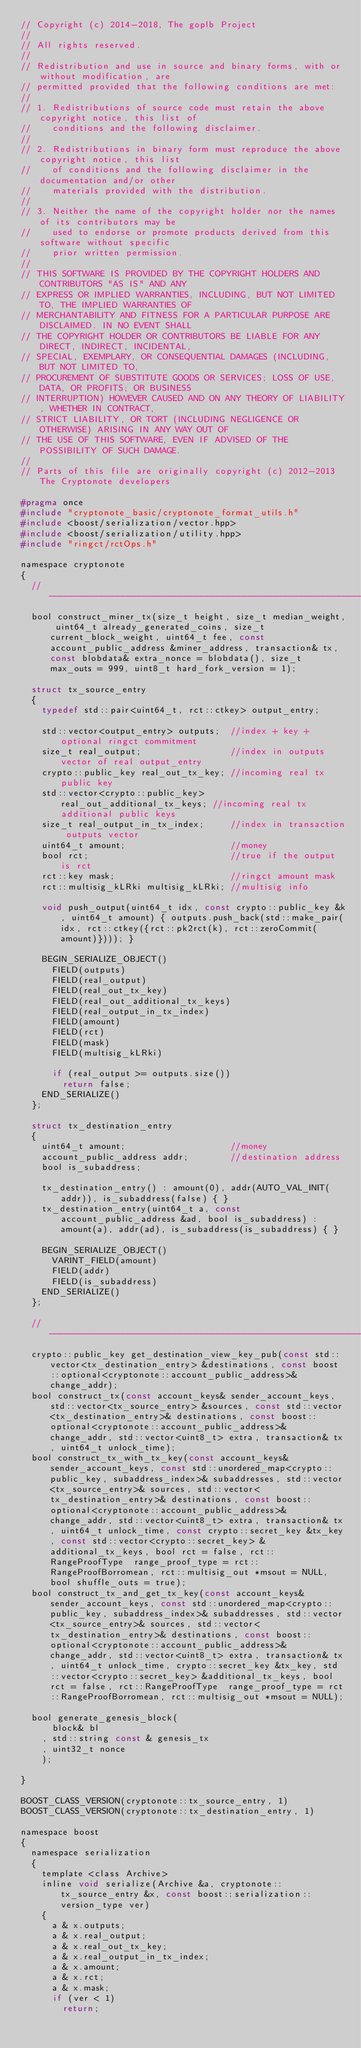Convert code to text. <code><loc_0><loc_0><loc_500><loc_500><_C_>// Copyright (c) 2014-2018, The goplb Project
// 
// All rights reserved.
// 
// Redistribution and use in source and binary forms, with or without modification, are
// permitted provided that the following conditions are met:
// 
// 1. Redistributions of source code must retain the above copyright notice, this list of
//    conditions and the following disclaimer.
// 
// 2. Redistributions in binary form must reproduce the above copyright notice, this list
//    of conditions and the following disclaimer in the documentation and/or other
//    materials provided with the distribution.
// 
// 3. Neither the name of the copyright holder nor the names of its contributors may be
//    used to endorse or promote products derived from this software without specific
//    prior written permission.
// 
// THIS SOFTWARE IS PROVIDED BY THE COPYRIGHT HOLDERS AND CONTRIBUTORS "AS IS" AND ANY
// EXPRESS OR IMPLIED WARRANTIES, INCLUDING, BUT NOT LIMITED TO, THE IMPLIED WARRANTIES OF
// MERCHANTABILITY AND FITNESS FOR A PARTICULAR PURPOSE ARE DISCLAIMED. IN NO EVENT SHALL
// THE COPYRIGHT HOLDER OR CONTRIBUTORS BE LIABLE FOR ANY DIRECT, INDIRECT, INCIDENTAL,
// SPECIAL, EXEMPLARY, OR CONSEQUENTIAL DAMAGES (INCLUDING, BUT NOT LIMITED TO,
// PROCUREMENT OF SUBSTITUTE GOODS OR SERVICES; LOSS OF USE, DATA, OR PROFITS; OR BUSINESS
// INTERRUPTION) HOWEVER CAUSED AND ON ANY THEORY OF LIABILITY, WHETHER IN CONTRACT,
// STRICT LIABILITY, OR TORT (INCLUDING NEGLIGENCE OR OTHERWISE) ARISING IN ANY WAY OUT OF
// THE USE OF THIS SOFTWARE, EVEN IF ADVISED OF THE POSSIBILITY OF SUCH DAMAGE.
// 
// Parts of this file are originally copyright (c) 2012-2013 The Cryptonote developers

#pragma once
#include "cryptonote_basic/cryptonote_format_utils.h"
#include <boost/serialization/vector.hpp>
#include <boost/serialization/utility.hpp>
#include "ringct/rctOps.h"

namespace cryptonote
{
  //---------------------------------------------------------------
  bool construct_miner_tx(size_t height, size_t median_weight, uint64_t already_generated_coins, size_t current_block_weight, uint64_t fee, const account_public_address &miner_address, transaction& tx, const blobdata& extra_nonce = blobdata(), size_t max_outs = 999, uint8_t hard_fork_version = 1);

  struct tx_source_entry
  {
    typedef std::pair<uint64_t, rct::ctkey> output_entry;

    std::vector<output_entry> outputs;  //index + key + optional ringct commitment
    size_t real_output;                 //index in outputs vector of real output_entry
    crypto::public_key real_out_tx_key; //incoming real tx public key
    std::vector<crypto::public_key> real_out_additional_tx_keys; //incoming real tx additional public keys
    size_t real_output_in_tx_index;     //index in transaction outputs vector
    uint64_t amount;                    //money
    bool rct;                           //true if the output is rct
    rct::key mask;                      //ringct amount mask
    rct::multisig_kLRki multisig_kLRki; //multisig info

    void push_output(uint64_t idx, const crypto::public_key &k, uint64_t amount) { outputs.push_back(std::make_pair(idx, rct::ctkey({rct::pk2rct(k), rct::zeroCommit(amount)}))); }

    BEGIN_SERIALIZE_OBJECT()
      FIELD(outputs)
      FIELD(real_output)
      FIELD(real_out_tx_key)
      FIELD(real_out_additional_tx_keys)
      FIELD(real_output_in_tx_index)
      FIELD(amount)
      FIELD(rct)
      FIELD(mask)
      FIELD(multisig_kLRki)

      if (real_output >= outputs.size())
        return false;
    END_SERIALIZE()
  };

  struct tx_destination_entry
  {
    uint64_t amount;                    //money
    account_public_address addr;        //destination address
    bool is_subaddress;

    tx_destination_entry() : amount(0), addr(AUTO_VAL_INIT(addr)), is_subaddress(false) { }
    tx_destination_entry(uint64_t a, const account_public_address &ad, bool is_subaddress) : amount(a), addr(ad), is_subaddress(is_subaddress) { }

    BEGIN_SERIALIZE_OBJECT()
      VARINT_FIELD(amount)
      FIELD(addr)
      FIELD(is_subaddress)
    END_SERIALIZE()
  };

  //---------------------------------------------------------------
  crypto::public_key get_destination_view_key_pub(const std::vector<tx_destination_entry> &destinations, const boost::optional<cryptonote::account_public_address>& change_addr);
  bool construct_tx(const account_keys& sender_account_keys, std::vector<tx_source_entry> &sources, const std::vector<tx_destination_entry>& destinations, const boost::optional<cryptonote::account_public_address>& change_addr, std::vector<uint8_t> extra, transaction& tx, uint64_t unlock_time);
  bool construct_tx_with_tx_key(const account_keys& sender_account_keys, const std::unordered_map<crypto::public_key, subaddress_index>& subaddresses, std::vector<tx_source_entry>& sources, std::vector<tx_destination_entry>& destinations, const boost::optional<cryptonote::account_public_address>& change_addr, std::vector<uint8_t> extra, transaction& tx, uint64_t unlock_time, const crypto::secret_key &tx_key, const std::vector<crypto::secret_key> &additional_tx_keys, bool rct = false, rct::RangeProofType  range_proof_type = rct::RangeProofBorromean, rct::multisig_out *msout = NULL, bool shuffle_outs = true);
  bool construct_tx_and_get_tx_key(const account_keys& sender_account_keys, const std::unordered_map<crypto::public_key, subaddress_index>& subaddresses, std::vector<tx_source_entry>& sources, std::vector<tx_destination_entry>& destinations, const boost::optional<cryptonote::account_public_address>& change_addr, std::vector<uint8_t> extra, transaction& tx, uint64_t unlock_time, crypto::secret_key &tx_key, std::vector<crypto::secret_key> &additional_tx_keys, bool rct = false, rct::RangeProofType  range_proof_type = rct::RangeProofBorromean, rct::multisig_out *msout = NULL);

  bool generate_genesis_block(
      block& bl
    , std::string const & genesis_tx
    , uint32_t nonce
    );

}

BOOST_CLASS_VERSION(cryptonote::tx_source_entry, 1)
BOOST_CLASS_VERSION(cryptonote::tx_destination_entry, 1)

namespace boost
{
  namespace serialization
  {
    template <class Archive>
    inline void serialize(Archive &a, cryptonote::tx_source_entry &x, const boost::serialization::version_type ver)
    {
      a & x.outputs;
      a & x.real_output;
      a & x.real_out_tx_key;
      a & x.real_output_in_tx_index;
      a & x.amount;
      a & x.rct;
      a & x.mask;
      if (ver < 1)
        return;</code> 